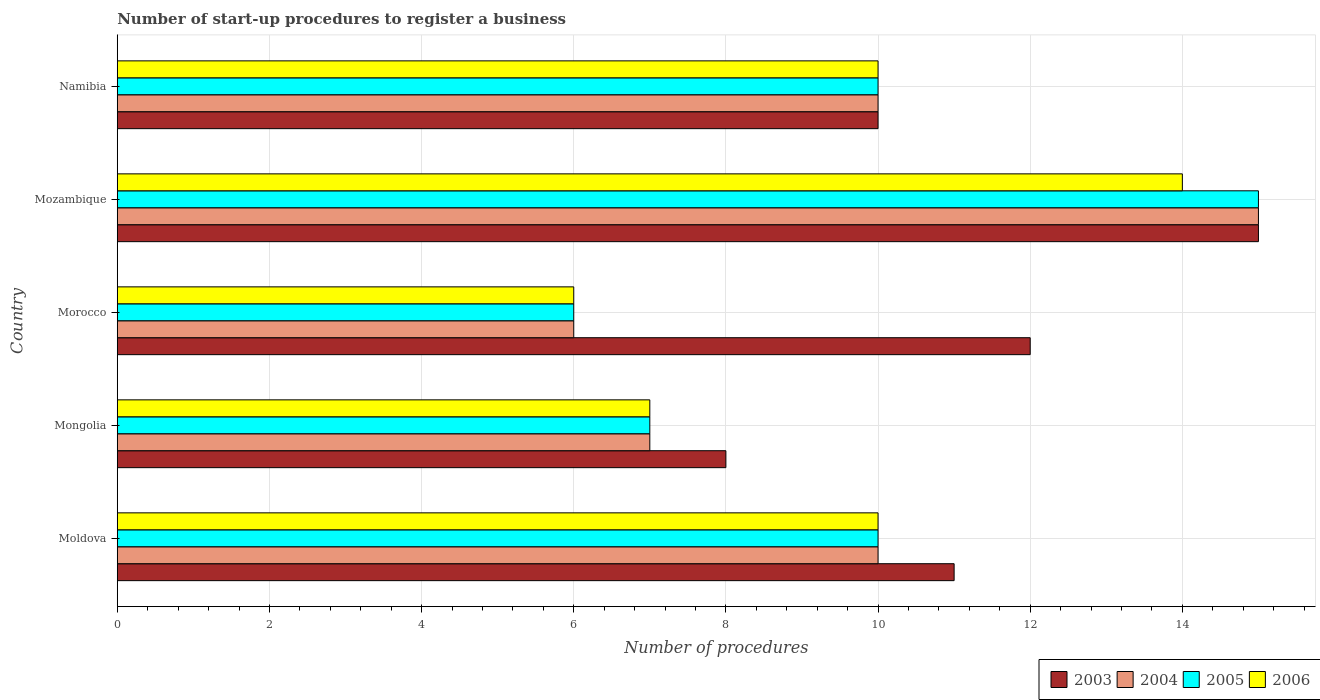How many different coloured bars are there?
Offer a terse response. 4. Are the number of bars per tick equal to the number of legend labels?
Ensure brevity in your answer.  Yes. What is the label of the 2nd group of bars from the top?
Provide a succinct answer. Mozambique. In how many cases, is the number of bars for a given country not equal to the number of legend labels?
Your answer should be compact. 0. Across all countries, what is the minimum number of procedures required to register a business in 2003?
Ensure brevity in your answer.  8. In which country was the number of procedures required to register a business in 2003 maximum?
Give a very brief answer. Mozambique. In which country was the number of procedures required to register a business in 2004 minimum?
Offer a terse response. Morocco. What is the total number of procedures required to register a business in 2006 in the graph?
Ensure brevity in your answer.  47. What is the average number of procedures required to register a business in 2004 per country?
Keep it short and to the point. 9.6. What is the difference between the number of procedures required to register a business in 2004 and number of procedures required to register a business in 2003 in Mongolia?
Your response must be concise. -1. Is the number of procedures required to register a business in 2003 in Morocco less than that in Namibia?
Keep it short and to the point. No. Is the difference between the number of procedures required to register a business in 2004 in Mozambique and Namibia greater than the difference between the number of procedures required to register a business in 2003 in Mozambique and Namibia?
Give a very brief answer. No. What is the difference between the highest and the second highest number of procedures required to register a business in 2004?
Make the answer very short. 5. In how many countries, is the number of procedures required to register a business in 2006 greater than the average number of procedures required to register a business in 2006 taken over all countries?
Provide a succinct answer. 3. Is the sum of the number of procedures required to register a business in 2004 in Mozambique and Namibia greater than the maximum number of procedures required to register a business in 2003 across all countries?
Your response must be concise. Yes. Is it the case that in every country, the sum of the number of procedures required to register a business in 2003 and number of procedures required to register a business in 2004 is greater than the sum of number of procedures required to register a business in 2006 and number of procedures required to register a business in 2005?
Provide a succinct answer. No. What does the 4th bar from the bottom in Mongolia represents?
Provide a short and direct response. 2006. Are all the bars in the graph horizontal?
Offer a very short reply. Yes. What is the difference between two consecutive major ticks on the X-axis?
Provide a succinct answer. 2. How many legend labels are there?
Make the answer very short. 4. How are the legend labels stacked?
Your answer should be compact. Horizontal. What is the title of the graph?
Provide a succinct answer. Number of start-up procedures to register a business. What is the label or title of the X-axis?
Offer a terse response. Number of procedures. What is the Number of procedures in 2003 in Moldova?
Provide a short and direct response. 11. What is the Number of procedures in 2004 in Moldova?
Your answer should be very brief. 10. What is the Number of procedures of 2005 in Moldova?
Your response must be concise. 10. What is the Number of procedures in 2004 in Mongolia?
Your answer should be compact. 7. What is the Number of procedures in 2005 in Mongolia?
Ensure brevity in your answer.  7. What is the Number of procedures of 2006 in Mongolia?
Keep it short and to the point. 7. What is the Number of procedures of 2004 in Morocco?
Keep it short and to the point. 6. What is the Number of procedures of 2005 in Morocco?
Offer a very short reply. 6. What is the Number of procedures of 2006 in Morocco?
Provide a short and direct response. 6. What is the Number of procedures in 2003 in Namibia?
Ensure brevity in your answer.  10. What is the Number of procedures in 2006 in Namibia?
Keep it short and to the point. 10. Across all countries, what is the minimum Number of procedures in 2004?
Provide a short and direct response. 6. Across all countries, what is the minimum Number of procedures in 2005?
Offer a terse response. 6. Across all countries, what is the minimum Number of procedures in 2006?
Give a very brief answer. 6. What is the total Number of procedures of 2004 in the graph?
Keep it short and to the point. 48. What is the difference between the Number of procedures of 2006 in Moldova and that in Mongolia?
Ensure brevity in your answer.  3. What is the difference between the Number of procedures in 2004 in Moldova and that in Morocco?
Your answer should be very brief. 4. What is the difference between the Number of procedures in 2006 in Moldova and that in Morocco?
Offer a terse response. 4. What is the difference between the Number of procedures of 2003 in Moldova and that in Mozambique?
Keep it short and to the point. -4. What is the difference between the Number of procedures in 2004 in Moldova and that in Mozambique?
Offer a very short reply. -5. What is the difference between the Number of procedures of 2005 in Moldova and that in Mozambique?
Your answer should be compact. -5. What is the difference between the Number of procedures in 2006 in Moldova and that in Namibia?
Offer a very short reply. 0. What is the difference between the Number of procedures in 2004 in Mongolia and that in Morocco?
Keep it short and to the point. 1. What is the difference between the Number of procedures of 2006 in Mongolia and that in Morocco?
Your answer should be very brief. 1. What is the difference between the Number of procedures in 2004 in Mongolia and that in Mozambique?
Your response must be concise. -8. What is the difference between the Number of procedures in 2005 in Mongolia and that in Mozambique?
Keep it short and to the point. -8. What is the difference between the Number of procedures of 2006 in Morocco and that in Mozambique?
Provide a succinct answer. -8. What is the difference between the Number of procedures of 2004 in Morocco and that in Namibia?
Ensure brevity in your answer.  -4. What is the difference between the Number of procedures of 2006 in Morocco and that in Namibia?
Give a very brief answer. -4. What is the difference between the Number of procedures in 2003 in Mozambique and that in Namibia?
Your response must be concise. 5. What is the difference between the Number of procedures of 2006 in Mozambique and that in Namibia?
Your response must be concise. 4. What is the difference between the Number of procedures of 2003 in Moldova and the Number of procedures of 2004 in Mongolia?
Provide a succinct answer. 4. What is the difference between the Number of procedures of 2005 in Moldova and the Number of procedures of 2006 in Mongolia?
Ensure brevity in your answer.  3. What is the difference between the Number of procedures in 2003 in Moldova and the Number of procedures in 2004 in Morocco?
Make the answer very short. 5. What is the difference between the Number of procedures of 2004 in Moldova and the Number of procedures of 2006 in Morocco?
Offer a very short reply. 4. What is the difference between the Number of procedures of 2003 in Moldova and the Number of procedures of 2006 in Mozambique?
Your answer should be compact. -3. What is the difference between the Number of procedures in 2004 in Moldova and the Number of procedures in 2005 in Mozambique?
Offer a terse response. -5. What is the difference between the Number of procedures in 2005 in Moldova and the Number of procedures in 2006 in Mozambique?
Provide a short and direct response. -4. What is the difference between the Number of procedures in 2003 in Moldova and the Number of procedures in 2006 in Namibia?
Provide a short and direct response. 1. What is the difference between the Number of procedures of 2004 in Moldova and the Number of procedures of 2005 in Namibia?
Your response must be concise. 0. What is the difference between the Number of procedures in 2004 in Moldova and the Number of procedures in 2006 in Namibia?
Provide a succinct answer. 0. What is the difference between the Number of procedures in 2005 in Moldova and the Number of procedures in 2006 in Namibia?
Offer a very short reply. 0. What is the difference between the Number of procedures of 2003 in Mongolia and the Number of procedures of 2004 in Morocco?
Offer a terse response. 2. What is the difference between the Number of procedures in 2003 in Mongolia and the Number of procedures in 2005 in Morocco?
Keep it short and to the point. 2. What is the difference between the Number of procedures of 2003 in Mongolia and the Number of procedures of 2006 in Morocco?
Provide a succinct answer. 2. What is the difference between the Number of procedures in 2005 in Mongolia and the Number of procedures in 2006 in Morocco?
Keep it short and to the point. 1. What is the difference between the Number of procedures in 2003 in Mongolia and the Number of procedures in 2004 in Mozambique?
Provide a short and direct response. -7. What is the difference between the Number of procedures of 2003 in Mongolia and the Number of procedures of 2005 in Mozambique?
Offer a very short reply. -7. What is the difference between the Number of procedures of 2004 in Mongolia and the Number of procedures of 2005 in Namibia?
Offer a terse response. -3. What is the difference between the Number of procedures of 2004 in Mongolia and the Number of procedures of 2006 in Namibia?
Provide a succinct answer. -3. What is the difference between the Number of procedures of 2005 in Mongolia and the Number of procedures of 2006 in Namibia?
Ensure brevity in your answer.  -3. What is the difference between the Number of procedures of 2003 in Morocco and the Number of procedures of 2004 in Mozambique?
Keep it short and to the point. -3. What is the difference between the Number of procedures of 2004 in Morocco and the Number of procedures of 2005 in Mozambique?
Give a very brief answer. -9. What is the difference between the Number of procedures of 2003 in Morocco and the Number of procedures of 2004 in Namibia?
Make the answer very short. 2. What is the difference between the Number of procedures in 2004 in Morocco and the Number of procedures in 2006 in Namibia?
Provide a succinct answer. -4. What is the difference between the Number of procedures of 2005 in Morocco and the Number of procedures of 2006 in Namibia?
Give a very brief answer. -4. What is the difference between the Number of procedures of 2003 in Mozambique and the Number of procedures of 2004 in Namibia?
Your answer should be very brief. 5. What is the difference between the Number of procedures of 2003 in Mozambique and the Number of procedures of 2005 in Namibia?
Your answer should be very brief. 5. What is the difference between the Number of procedures of 2003 in Mozambique and the Number of procedures of 2006 in Namibia?
Offer a terse response. 5. What is the average Number of procedures in 2003 per country?
Provide a succinct answer. 11.2. What is the average Number of procedures in 2004 per country?
Give a very brief answer. 9.6. What is the average Number of procedures of 2006 per country?
Your response must be concise. 9.4. What is the difference between the Number of procedures in 2003 and Number of procedures in 2006 in Moldova?
Your answer should be very brief. 1. What is the difference between the Number of procedures in 2004 and Number of procedures in 2005 in Moldova?
Provide a short and direct response. 0. What is the difference between the Number of procedures in 2004 and Number of procedures in 2006 in Moldova?
Make the answer very short. 0. What is the difference between the Number of procedures in 2005 and Number of procedures in 2006 in Mongolia?
Make the answer very short. 0. What is the difference between the Number of procedures of 2003 and Number of procedures of 2004 in Morocco?
Keep it short and to the point. 6. What is the difference between the Number of procedures of 2004 and Number of procedures of 2005 in Morocco?
Your answer should be very brief. 0. What is the difference between the Number of procedures in 2003 and Number of procedures in 2005 in Mozambique?
Your answer should be very brief. 0. What is the difference between the Number of procedures in 2003 and Number of procedures in 2006 in Mozambique?
Keep it short and to the point. 1. What is the difference between the Number of procedures of 2005 and Number of procedures of 2006 in Mozambique?
Provide a short and direct response. 1. What is the difference between the Number of procedures of 2003 and Number of procedures of 2005 in Namibia?
Your response must be concise. 0. What is the difference between the Number of procedures in 2005 and Number of procedures in 2006 in Namibia?
Your answer should be very brief. 0. What is the ratio of the Number of procedures of 2003 in Moldova to that in Mongolia?
Your answer should be very brief. 1.38. What is the ratio of the Number of procedures in 2004 in Moldova to that in Mongolia?
Ensure brevity in your answer.  1.43. What is the ratio of the Number of procedures of 2005 in Moldova to that in Mongolia?
Give a very brief answer. 1.43. What is the ratio of the Number of procedures of 2006 in Moldova to that in Mongolia?
Offer a very short reply. 1.43. What is the ratio of the Number of procedures of 2006 in Moldova to that in Morocco?
Your response must be concise. 1.67. What is the ratio of the Number of procedures in 2003 in Moldova to that in Mozambique?
Offer a very short reply. 0.73. What is the ratio of the Number of procedures in 2005 in Moldova to that in Mozambique?
Ensure brevity in your answer.  0.67. What is the ratio of the Number of procedures of 2003 in Mongolia to that in Morocco?
Keep it short and to the point. 0.67. What is the ratio of the Number of procedures of 2005 in Mongolia to that in Morocco?
Provide a short and direct response. 1.17. What is the ratio of the Number of procedures of 2003 in Mongolia to that in Mozambique?
Offer a very short reply. 0.53. What is the ratio of the Number of procedures of 2004 in Mongolia to that in Mozambique?
Your response must be concise. 0.47. What is the ratio of the Number of procedures in 2005 in Mongolia to that in Mozambique?
Offer a terse response. 0.47. What is the ratio of the Number of procedures of 2003 in Mongolia to that in Namibia?
Ensure brevity in your answer.  0.8. What is the ratio of the Number of procedures in 2006 in Mongolia to that in Namibia?
Offer a very short reply. 0.7. What is the ratio of the Number of procedures of 2003 in Morocco to that in Mozambique?
Keep it short and to the point. 0.8. What is the ratio of the Number of procedures in 2005 in Morocco to that in Mozambique?
Provide a short and direct response. 0.4. What is the ratio of the Number of procedures of 2006 in Morocco to that in Mozambique?
Keep it short and to the point. 0.43. What is the ratio of the Number of procedures in 2003 in Morocco to that in Namibia?
Offer a very short reply. 1.2. What is the ratio of the Number of procedures in 2004 in Morocco to that in Namibia?
Your response must be concise. 0.6. What is the ratio of the Number of procedures of 2006 in Mozambique to that in Namibia?
Give a very brief answer. 1.4. What is the difference between the highest and the second highest Number of procedures of 2005?
Your response must be concise. 5. What is the difference between the highest and the second highest Number of procedures of 2006?
Make the answer very short. 4. What is the difference between the highest and the lowest Number of procedures in 2003?
Your answer should be very brief. 7. What is the difference between the highest and the lowest Number of procedures in 2005?
Ensure brevity in your answer.  9. What is the difference between the highest and the lowest Number of procedures of 2006?
Provide a short and direct response. 8. 